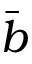Convert formula to latex. <formula><loc_0><loc_0><loc_500><loc_500>\bar { b }</formula> 